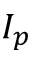Convert formula to latex. <formula><loc_0><loc_0><loc_500><loc_500>I _ { p }</formula> 